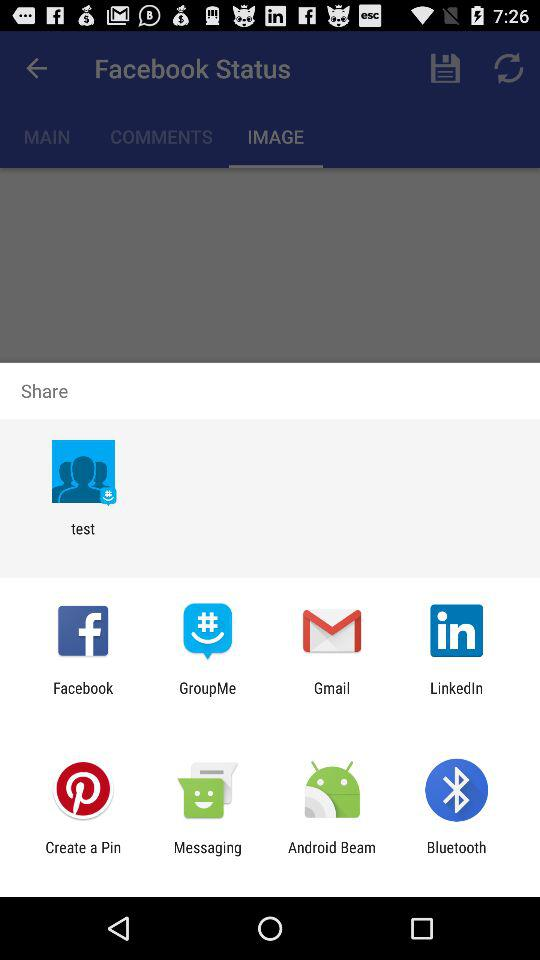Through which applications can we share? You can share with "test", "Facebook", "GroupMe", "Gmail", "LinkedIn", "Create a Pin", "Messaging", "Android Beam" and "Bluetooth". 